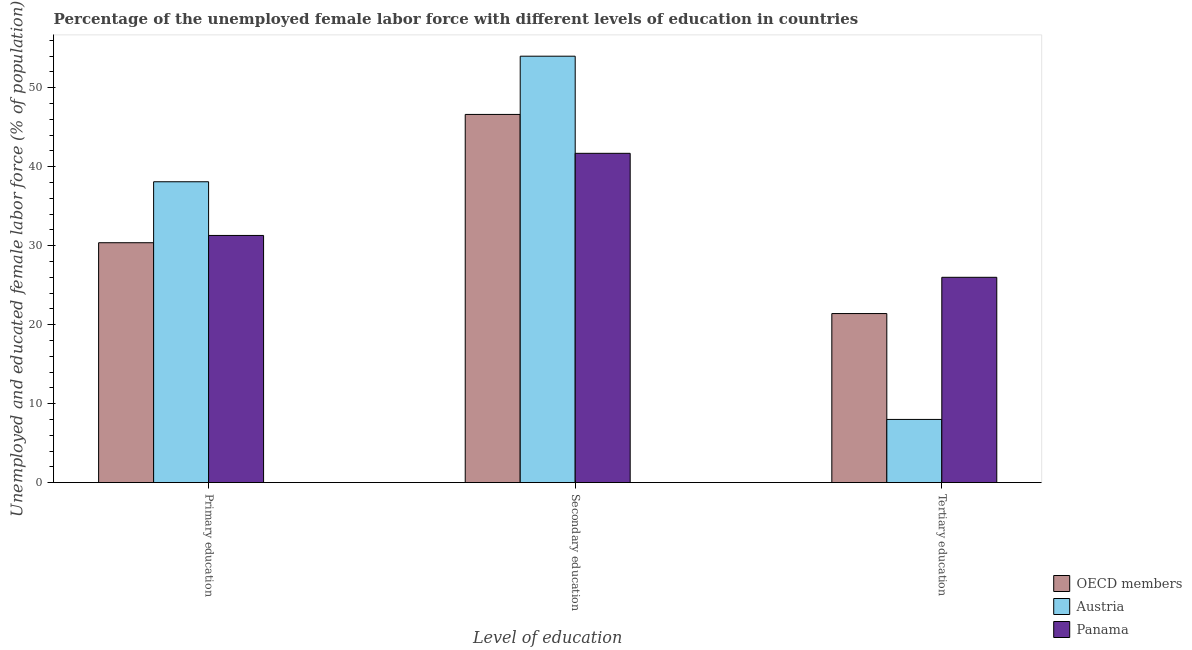How many different coloured bars are there?
Give a very brief answer. 3. How many bars are there on the 1st tick from the left?
Offer a terse response. 3. What is the label of the 2nd group of bars from the left?
Your answer should be compact. Secondary education. What is the percentage of female labor force who received secondary education in Austria?
Your answer should be compact. 54. Across all countries, what is the maximum percentage of female labor force who received secondary education?
Ensure brevity in your answer.  54. Across all countries, what is the minimum percentage of female labor force who received primary education?
Keep it short and to the point. 30.38. In which country was the percentage of female labor force who received secondary education minimum?
Make the answer very short. Panama. What is the total percentage of female labor force who received primary education in the graph?
Your answer should be very brief. 99.78. What is the difference between the percentage of female labor force who received secondary education in Panama and that in Austria?
Offer a terse response. -12.3. What is the difference between the percentage of female labor force who received tertiary education in OECD members and the percentage of female labor force who received secondary education in Austria?
Ensure brevity in your answer.  -32.59. What is the average percentage of female labor force who received tertiary education per country?
Your response must be concise. 18.47. What is the difference between the percentage of female labor force who received primary education and percentage of female labor force who received tertiary education in Panama?
Make the answer very short. 5.3. What is the ratio of the percentage of female labor force who received tertiary education in OECD members to that in Austria?
Give a very brief answer. 2.68. Is the difference between the percentage of female labor force who received tertiary education in Panama and OECD members greater than the difference between the percentage of female labor force who received primary education in Panama and OECD members?
Give a very brief answer. Yes. What is the difference between the highest and the second highest percentage of female labor force who received primary education?
Provide a succinct answer. 6.8. What is the difference between the highest and the lowest percentage of female labor force who received secondary education?
Offer a terse response. 12.3. In how many countries, is the percentage of female labor force who received primary education greater than the average percentage of female labor force who received primary education taken over all countries?
Give a very brief answer. 1. Is the sum of the percentage of female labor force who received primary education in OECD members and Austria greater than the maximum percentage of female labor force who received tertiary education across all countries?
Keep it short and to the point. Yes. What does the 3rd bar from the left in Primary education represents?
Make the answer very short. Panama. What does the 1st bar from the right in Secondary education represents?
Your response must be concise. Panama. How many bars are there?
Make the answer very short. 9. Are all the bars in the graph horizontal?
Your answer should be very brief. No. What is the difference between two consecutive major ticks on the Y-axis?
Provide a short and direct response. 10. Where does the legend appear in the graph?
Give a very brief answer. Bottom right. How are the legend labels stacked?
Provide a succinct answer. Vertical. What is the title of the graph?
Provide a short and direct response. Percentage of the unemployed female labor force with different levels of education in countries. What is the label or title of the X-axis?
Offer a terse response. Level of education. What is the label or title of the Y-axis?
Your response must be concise. Unemployed and educated female labor force (% of population). What is the Unemployed and educated female labor force (% of population) in OECD members in Primary education?
Ensure brevity in your answer.  30.38. What is the Unemployed and educated female labor force (% of population) in Austria in Primary education?
Provide a succinct answer. 38.1. What is the Unemployed and educated female labor force (% of population) of Panama in Primary education?
Provide a short and direct response. 31.3. What is the Unemployed and educated female labor force (% of population) of OECD members in Secondary education?
Provide a short and direct response. 46.63. What is the Unemployed and educated female labor force (% of population) in Panama in Secondary education?
Offer a terse response. 41.7. What is the Unemployed and educated female labor force (% of population) in OECD members in Tertiary education?
Keep it short and to the point. 21.41. Across all Level of education, what is the maximum Unemployed and educated female labor force (% of population) in OECD members?
Ensure brevity in your answer.  46.63. Across all Level of education, what is the maximum Unemployed and educated female labor force (% of population) of Austria?
Provide a short and direct response. 54. Across all Level of education, what is the maximum Unemployed and educated female labor force (% of population) in Panama?
Make the answer very short. 41.7. Across all Level of education, what is the minimum Unemployed and educated female labor force (% of population) of OECD members?
Ensure brevity in your answer.  21.41. Across all Level of education, what is the minimum Unemployed and educated female labor force (% of population) in Austria?
Your answer should be compact. 8. Across all Level of education, what is the minimum Unemployed and educated female labor force (% of population) of Panama?
Your answer should be compact. 26. What is the total Unemployed and educated female labor force (% of population) of OECD members in the graph?
Ensure brevity in your answer.  98.41. What is the total Unemployed and educated female labor force (% of population) in Austria in the graph?
Your answer should be very brief. 100.1. What is the difference between the Unemployed and educated female labor force (% of population) of OECD members in Primary education and that in Secondary education?
Provide a succinct answer. -16.25. What is the difference between the Unemployed and educated female labor force (% of population) of Austria in Primary education and that in Secondary education?
Ensure brevity in your answer.  -15.9. What is the difference between the Unemployed and educated female labor force (% of population) in Panama in Primary education and that in Secondary education?
Offer a very short reply. -10.4. What is the difference between the Unemployed and educated female labor force (% of population) in OECD members in Primary education and that in Tertiary education?
Make the answer very short. 8.97. What is the difference between the Unemployed and educated female labor force (% of population) in Austria in Primary education and that in Tertiary education?
Provide a succinct answer. 30.1. What is the difference between the Unemployed and educated female labor force (% of population) in Panama in Primary education and that in Tertiary education?
Your answer should be compact. 5.3. What is the difference between the Unemployed and educated female labor force (% of population) in OECD members in Secondary education and that in Tertiary education?
Offer a terse response. 25.22. What is the difference between the Unemployed and educated female labor force (% of population) in OECD members in Primary education and the Unemployed and educated female labor force (% of population) in Austria in Secondary education?
Ensure brevity in your answer.  -23.62. What is the difference between the Unemployed and educated female labor force (% of population) of OECD members in Primary education and the Unemployed and educated female labor force (% of population) of Panama in Secondary education?
Offer a terse response. -11.32. What is the difference between the Unemployed and educated female labor force (% of population) in Austria in Primary education and the Unemployed and educated female labor force (% of population) in Panama in Secondary education?
Your answer should be compact. -3.6. What is the difference between the Unemployed and educated female labor force (% of population) in OECD members in Primary education and the Unemployed and educated female labor force (% of population) in Austria in Tertiary education?
Offer a terse response. 22.38. What is the difference between the Unemployed and educated female labor force (% of population) of OECD members in Primary education and the Unemployed and educated female labor force (% of population) of Panama in Tertiary education?
Provide a short and direct response. 4.38. What is the difference between the Unemployed and educated female labor force (% of population) of OECD members in Secondary education and the Unemployed and educated female labor force (% of population) of Austria in Tertiary education?
Your answer should be very brief. 38.63. What is the difference between the Unemployed and educated female labor force (% of population) in OECD members in Secondary education and the Unemployed and educated female labor force (% of population) in Panama in Tertiary education?
Your answer should be compact. 20.63. What is the average Unemployed and educated female labor force (% of population) in OECD members per Level of education?
Your answer should be very brief. 32.8. What is the average Unemployed and educated female labor force (% of population) of Austria per Level of education?
Your answer should be very brief. 33.37. What is the difference between the Unemployed and educated female labor force (% of population) of OECD members and Unemployed and educated female labor force (% of population) of Austria in Primary education?
Your answer should be compact. -7.72. What is the difference between the Unemployed and educated female labor force (% of population) in OECD members and Unemployed and educated female labor force (% of population) in Panama in Primary education?
Your answer should be compact. -0.92. What is the difference between the Unemployed and educated female labor force (% of population) in Austria and Unemployed and educated female labor force (% of population) in Panama in Primary education?
Offer a terse response. 6.8. What is the difference between the Unemployed and educated female labor force (% of population) in OECD members and Unemployed and educated female labor force (% of population) in Austria in Secondary education?
Your answer should be compact. -7.37. What is the difference between the Unemployed and educated female labor force (% of population) in OECD members and Unemployed and educated female labor force (% of population) in Panama in Secondary education?
Ensure brevity in your answer.  4.93. What is the difference between the Unemployed and educated female labor force (% of population) in Austria and Unemployed and educated female labor force (% of population) in Panama in Secondary education?
Your response must be concise. 12.3. What is the difference between the Unemployed and educated female labor force (% of population) of OECD members and Unemployed and educated female labor force (% of population) of Austria in Tertiary education?
Your response must be concise. 13.41. What is the difference between the Unemployed and educated female labor force (% of population) in OECD members and Unemployed and educated female labor force (% of population) in Panama in Tertiary education?
Ensure brevity in your answer.  -4.59. What is the difference between the Unemployed and educated female labor force (% of population) in Austria and Unemployed and educated female labor force (% of population) in Panama in Tertiary education?
Provide a short and direct response. -18. What is the ratio of the Unemployed and educated female labor force (% of population) of OECD members in Primary education to that in Secondary education?
Make the answer very short. 0.65. What is the ratio of the Unemployed and educated female labor force (% of population) of Austria in Primary education to that in Secondary education?
Keep it short and to the point. 0.71. What is the ratio of the Unemployed and educated female labor force (% of population) in Panama in Primary education to that in Secondary education?
Offer a terse response. 0.75. What is the ratio of the Unemployed and educated female labor force (% of population) of OECD members in Primary education to that in Tertiary education?
Provide a succinct answer. 1.42. What is the ratio of the Unemployed and educated female labor force (% of population) of Austria in Primary education to that in Tertiary education?
Your answer should be compact. 4.76. What is the ratio of the Unemployed and educated female labor force (% of population) in Panama in Primary education to that in Tertiary education?
Ensure brevity in your answer.  1.2. What is the ratio of the Unemployed and educated female labor force (% of population) in OECD members in Secondary education to that in Tertiary education?
Your answer should be compact. 2.18. What is the ratio of the Unemployed and educated female labor force (% of population) in Austria in Secondary education to that in Tertiary education?
Make the answer very short. 6.75. What is the ratio of the Unemployed and educated female labor force (% of population) of Panama in Secondary education to that in Tertiary education?
Give a very brief answer. 1.6. What is the difference between the highest and the second highest Unemployed and educated female labor force (% of population) in OECD members?
Your response must be concise. 16.25. What is the difference between the highest and the lowest Unemployed and educated female labor force (% of population) in OECD members?
Provide a short and direct response. 25.22. 